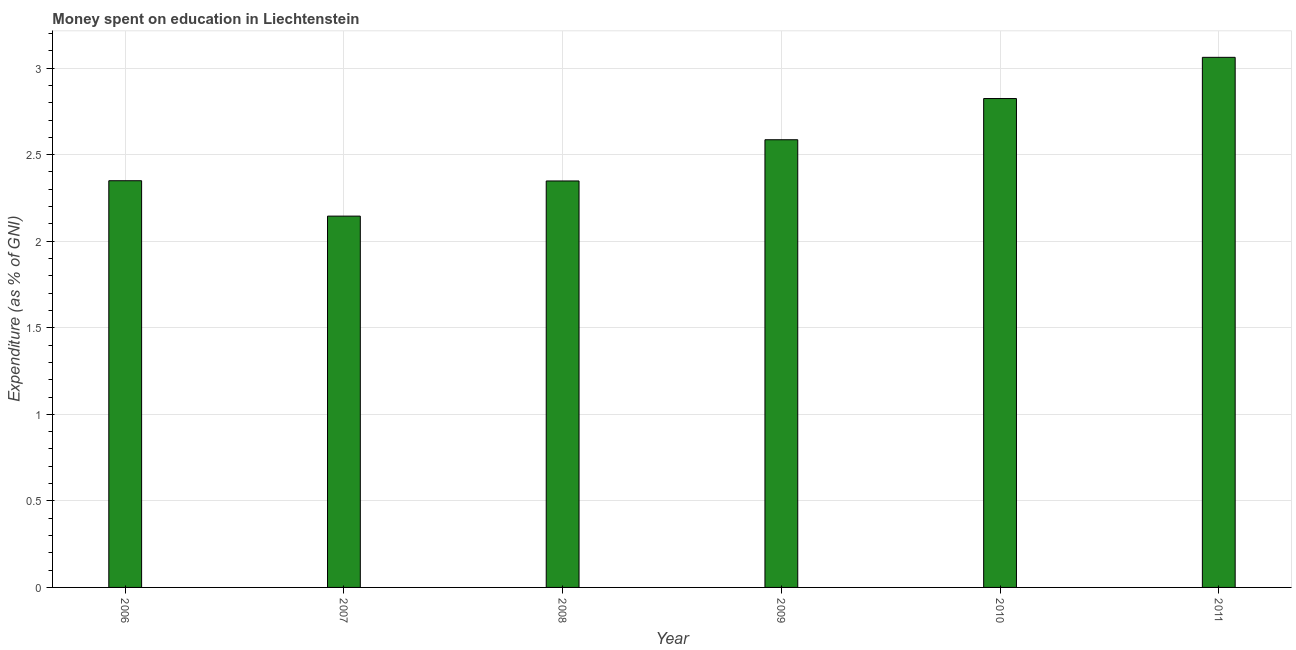Does the graph contain any zero values?
Provide a short and direct response. No. What is the title of the graph?
Your answer should be very brief. Money spent on education in Liechtenstein. What is the label or title of the Y-axis?
Your answer should be very brief. Expenditure (as % of GNI). What is the expenditure on education in 2009?
Ensure brevity in your answer.  2.59. Across all years, what is the maximum expenditure on education?
Keep it short and to the point. 3.06. Across all years, what is the minimum expenditure on education?
Ensure brevity in your answer.  2.14. In which year was the expenditure on education maximum?
Keep it short and to the point. 2011. In which year was the expenditure on education minimum?
Give a very brief answer. 2007. What is the sum of the expenditure on education?
Give a very brief answer. 15.31. What is the difference between the expenditure on education in 2006 and 2011?
Offer a terse response. -0.71. What is the average expenditure on education per year?
Offer a very short reply. 2.55. What is the median expenditure on education?
Ensure brevity in your answer.  2.47. Do a majority of the years between 2009 and 2010 (inclusive) have expenditure on education greater than 1.4 %?
Give a very brief answer. Yes. What is the ratio of the expenditure on education in 2006 to that in 2009?
Ensure brevity in your answer.  0.91. Is the difference between the expenditure on education in 2007 and 2011 greater than the difference between any two years?
Your answer should be compact. Yes. What is the difference between the highest and the second highest expenditure on education?
Your answer should be very brief. 0.24. What is the difference between the highest and the lowest expenditure on education?
Ensure brevity in your answer.  0.92. In how many years, is the expenditure on education greater than the average expenditure on education taken over all years?
Give a very brief answer. 3. How many bars are there?
Provide a short and direct response. 6. What is the difference between two consecutive major ticks on the Y-axis?
Make the answer very short. 0.5. What is the Expenditure (as % of GNI) in 2006?
Your answer should be compact. 2.35. What is the Expenditure (as % of GNI) in 2007?
Your answer should be compact. 2.14. What is the Expenditure (as % of GNI) of 2008?
Provide a succinct answer. 2.35. What is the Expenditure (as % of GNI) of 2009?
Your answer should be compact. 2.59. What is the Expenditure (as % of GNI) in 2010?
Your answer should be very brief. 2.82. What is the Expenditure (as % of GNI) of 2011?
Ensure brevity in your answer.  3.06. What is the difference between the Expenditure (as % of GNI) in 2006 and 2007?
Offer a very short reply. 0.2. What is the difference between the Expenditure (as % of GNI) in 2006 and 2008?
Make the answer very short. 0. What is the difference between the Expenditure (as % of GNI) in 2006 and 2009?
Offer a very short reply. -0.24. What is the difference between the Expenditure (as % of GNI) in 2006 and 2010?
Offer a terse response. -0.47. What is the difference between the Expenditure (as % of GNI) in 2006 and 2011?
Offer a very short reply. -0.71. What is the difference between the Expenditure (as % of GNI) in 2007 and 2008?
Offer a very short reply. -0.2. What is the difference between the Expenditure (as % of GNI) in 2007 and 2009?
Your answer should be compact. -0.44. What is the difference between the Expenditure (as % of GNI) in 2007 and 2010?
Your response must be concise. -0.68. What is the difference between the Expenditure (as % of GNI) in 2007 and 2011?
Your answer should be very brief. -0.92. What is the difference between the Expenditure (as % of GNI) in 2008 and 2009?
Provide a short and direct response. -0.24. What is the difference between the Expenditure (as % of GNI) in 2008 and 2010?
Provide a short and direct response. -0.48. What is the difference between the Expenditure (as % of GNI) in 2008 and 2011?
Ensure brevity in your answer.  -0.71. What is the difference between the Expenditure (as % of GNI) in 2009 and 2010?
Your answer should be very brief. -0.24. What is the difference between the Expenditure (as % of GNI) in 2009 and 2011?
Keep it short and to the point. -0.48. What is the difference between the Expenditure (as % of GNI) in 2010 and 2011?
Offer a terse response. -0.24. What is the ratio of the Expenditure (as % of GNI) in 2006 to that in 2007?
Ensure brevity in your answer.  1.09. What is the ratio of the Expenditure (as % of GNI) in 2006 to that in 2009?
Give a very brief answer. 0.91. What is the ratio of the Expenditure (as % of GNI) in 2006 to that in 2010?
Your answer should be very brief. 0.83. What is the ratio of the Expenditure (as % of GNI) in 2006 to that in 2011?
Provide a succinct answer. 0.77. What is the ratio of the Expenditure (as % of GNI) in 2007 to that in 2008?
Provide a succinct answer. 0.91. What is the ratio of the Expenditure (as % of GNI) in 2007 to that in 2009?
Make the answer very short. 0.83. What is the ratio of the Expenditure (as % of GNI) in 2007 to that in 2010?
Provide a succinct answer. 0.76. What is the ratio of the Expenditure (as % of GNI) in 2007 to that in 2011?
Your response must be concise. 0.7. What is the ratio of the Expenditure (as % of GNI) in 2008 to that in 2009?
Offer a very short reply. 0.91. What is the ratio of the Expenditure (as % of GNI) in 2008 to that in 2010?
Keep it short and to the point. 0.83. What is the ratio of the Expenditure (as % of GNI) in 2008 to that in 2011?
Your answer should be very brief. 0.77. What is the ratio of the Expenditure (as % of GNI) in 2009 to that in 2010?
Keep it short and to the point. 0.92. What is the ratio of the Expenditure (as % of GNI) in 2009 to that in 2011?
Your answer should be compact. 0.84. What is the ratio of the Expenditure (as % of GNI) in 2010 to that in 2011?
Your answer should be very brief. 0.92. 